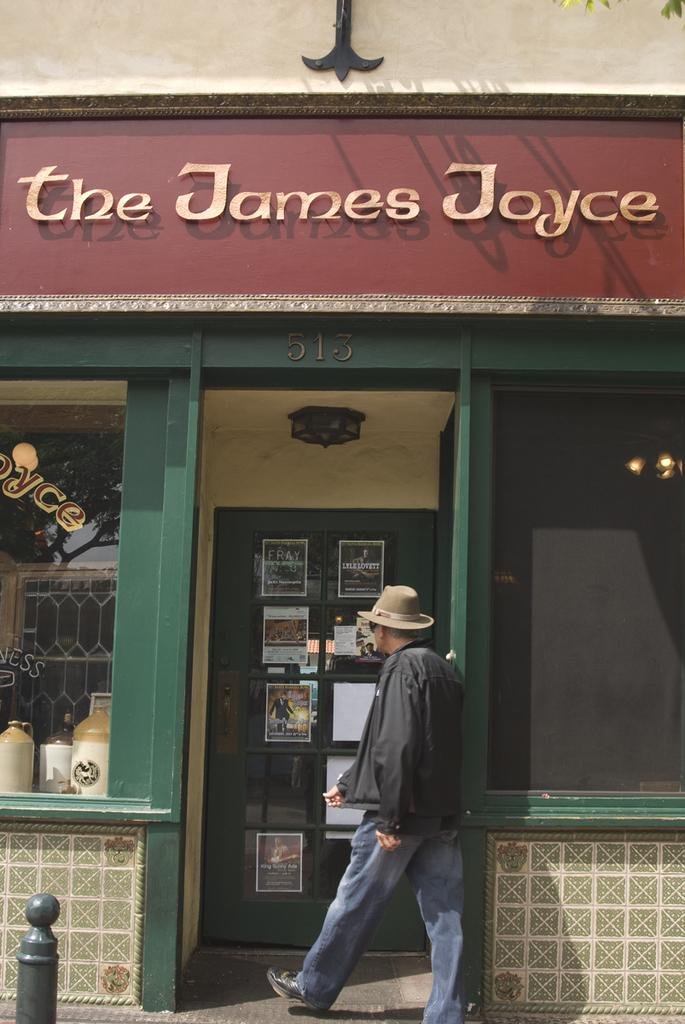What is the man in the image doing? The man is walking in the image. What can be seen on the man's head? The man is wearing a hat. What is one of the structures visible in the image? There is a pole in the image. What is one of the surfaces visible in the image? There is a wall in the image. What is one of the materials visible in the image? There is glass in the image. What is one of the flat surfaces visible in the image? There is a board in the image. What is one of the printed items visible in the image? There are posters in the image. What is one of the sources of illumination visible in the image? There are lights in the image. What is one of the general categories of items visible in the image? There are objects in the image. What type of destruction is being caused by the powder in the image? There is no powder or destruction present in the image. 